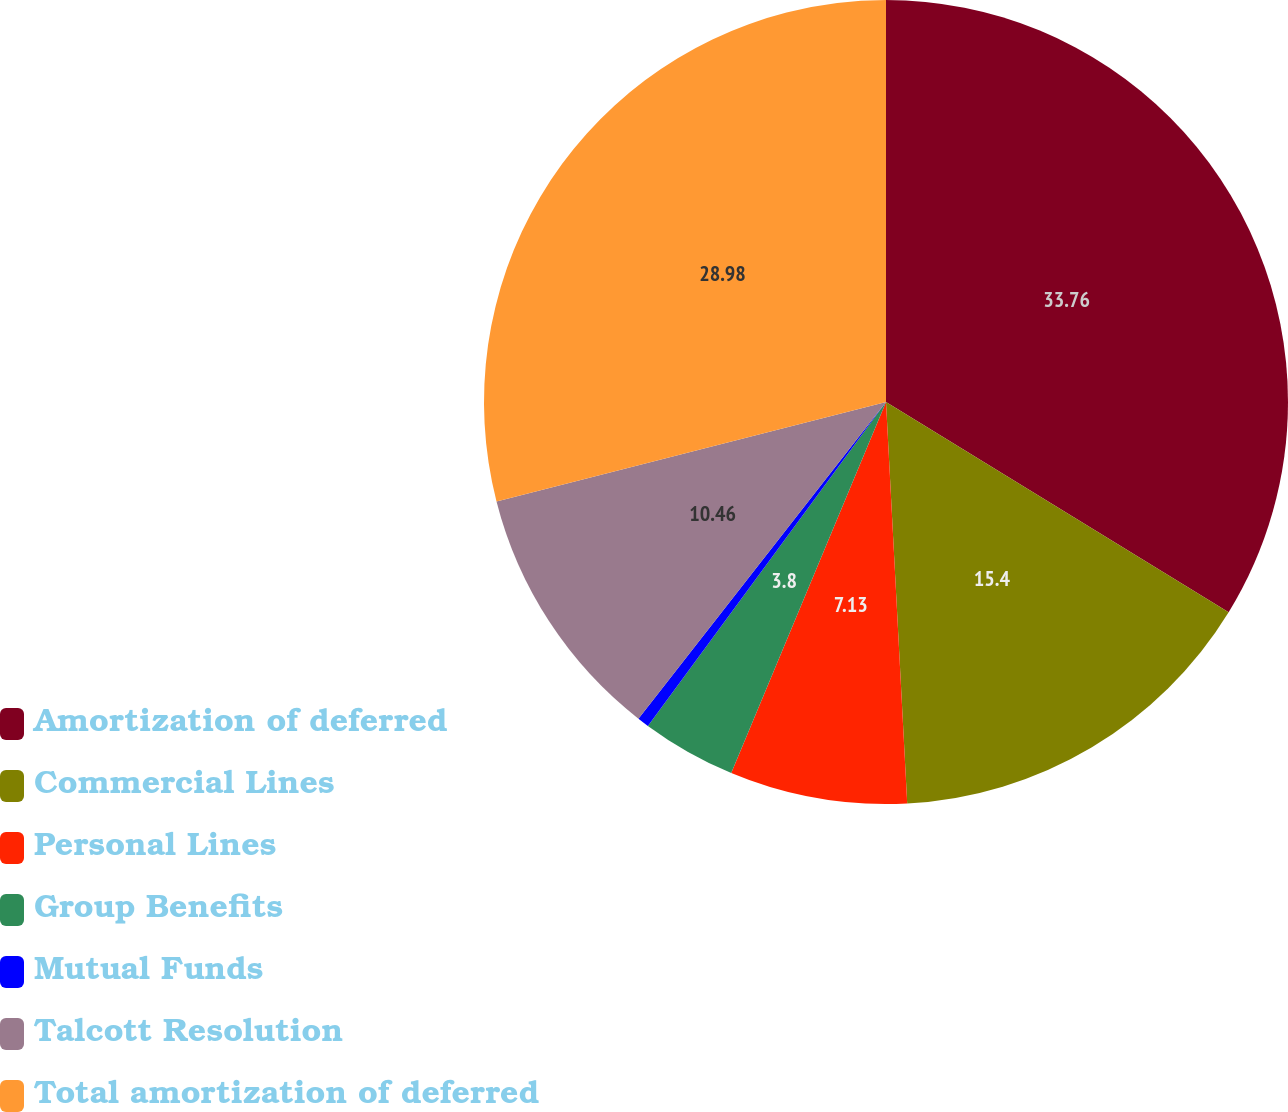Convert chart to OTSL. <chart><loc_0><loc_0><loc_500><loc_500><pie_chart><fcel>Amortization of deferred<fcel>Commercial Lines<fcel>Personal Lines<fcel>Group Benefits<fcel>Mutual Funds<fcel>Talcott Resolution<fcel>Total amortization of deferred<nl><fcel>33.76%<fcel>15.4%<fcel>7.13%<fcel>3.8%<fcel>0.47%<fcel>10.46%<fcel>28.98%<nl></chart> 